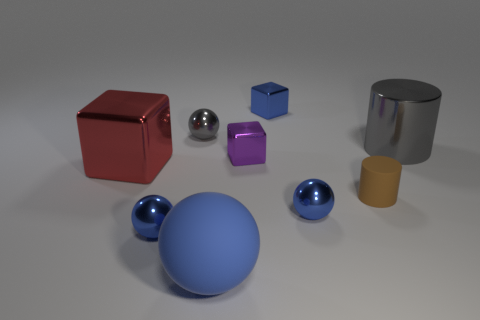There is a large blue object; is it the same shape as the large object that is behind the big metal block?
Provide a succinct answer. No. There is a rubber object on the left side of the brown cylinder; is it the same size as the big red metal block?
Give a very brief answer. Yes. What shape is the rubber thing that is the same size as the gray cylinder?
Provide a short and direct response. Sphere. Is the shape of the purple object the same as the small gray shiny thing?
Provide a short and direct response. No. What number of other tiny rubber objects are the same shape as the blue matte thing?
Your answer should be very brief. 0. There is a brown object; how many gray objects are on the left side of it?
Your answer should be compact. 1. There is a large thing that is left of the blue matte thing; does it have the same color as the large rubber thing?
Ensure brevity in your answer.  No. How many brown matte things are the same size as the red metallic block?
Your answer should be very brief. 0. There is a large red thing that is made of the same material as the blue cube; what shape is it?
Your answer should be very brief. Cube. Are there any things of the same color as the large metal cube?
Offer a terse response. No. 